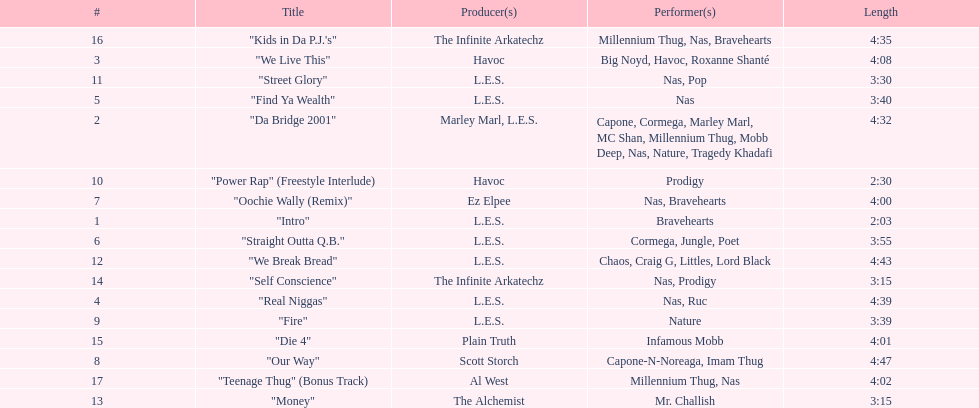How long is the longest track listed? 4:47. 